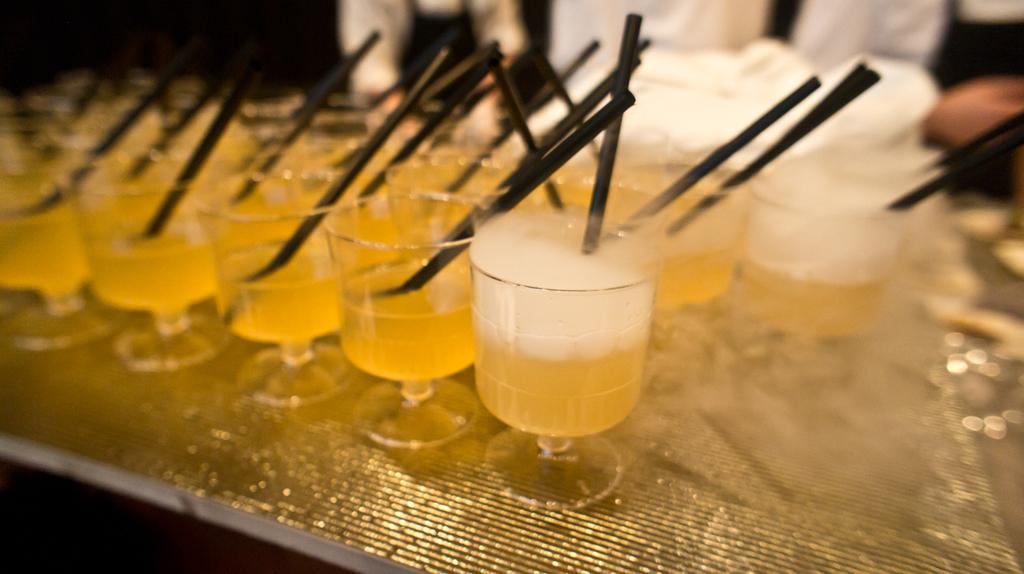What objects are present in the image? There are glasses, yellow-colored liquid, and black-colored sticks in the image. What is the color of the liquid in the glasses? The liquid in the glasses is yellow-colored. What might be used to stir or mix the liquid in the glasses? The black-colored sticks could be used to stir or mix the liquid in the glasses. What type of dress is the writer wearing in the image? There is no writer or dress present in the image; it only features glasses, yellow-colored liquid, and black-colored sticks. 